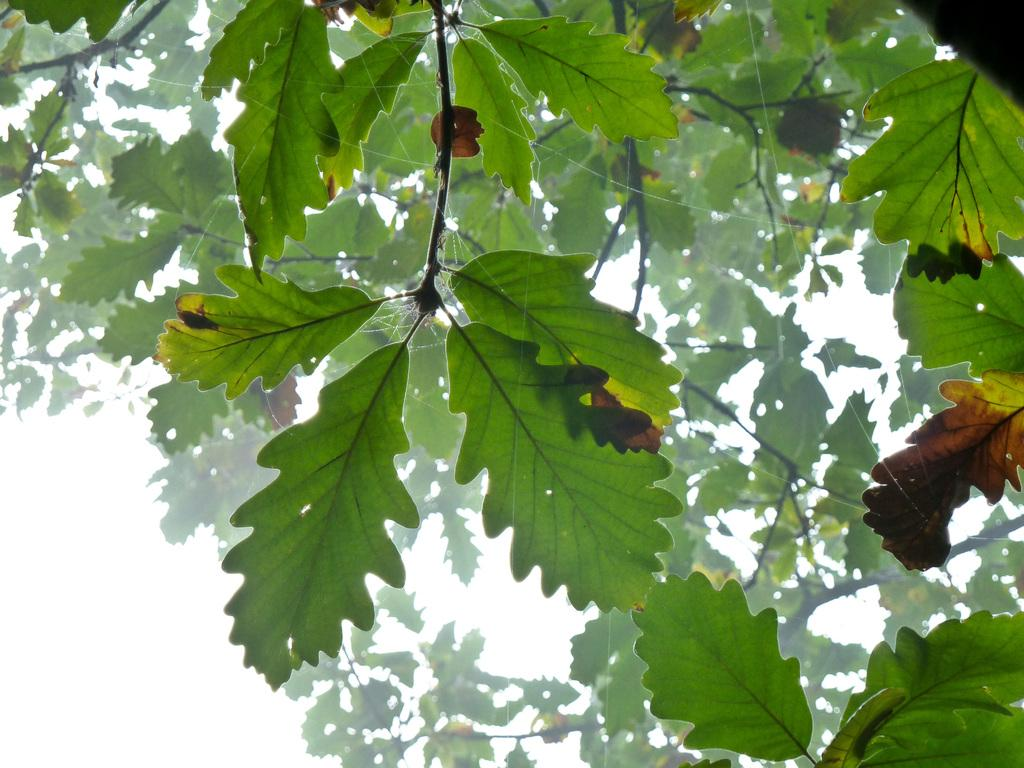What type of vegetation can be seen in the image? There are trees in the image. What part of the natural environment is visible in the image? The sky is visible in the background of the image. What type of breakfast is being served in the image? There is no breakfast present in the image; it only features trees and the sky. What time of day is it in the image? The time of day cannot be determined from the image, as it only shows trees and the sky. 